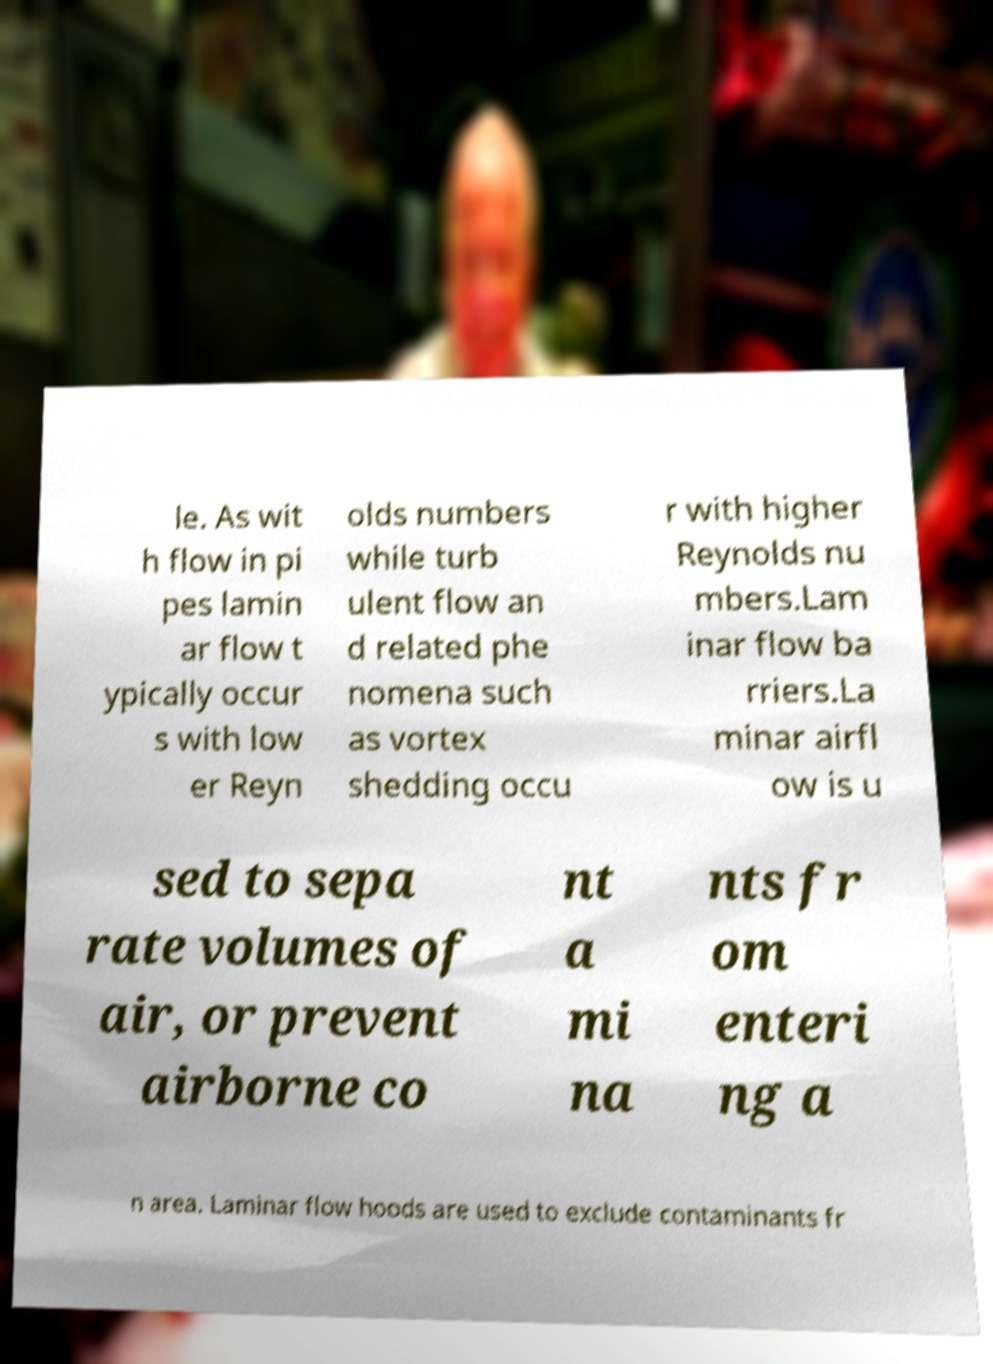Please read and relay the text visible in this image. What does it say? le. As wit h flow in pi pes lamin ar flow t ypically occur s with low er Reyn olds numbers while turb ulent flow an d related phe nomena such as vortex shedding occu r with higher Reynolds nu mbers.Lam inar flow ba rriers.La minar airfl ow is u sed to sepa rate volumes of air, or prevent airborne co nt a mi na nts fr om enteri ng a n area. Laminar flow hoods are used to exclude contaminants fr 